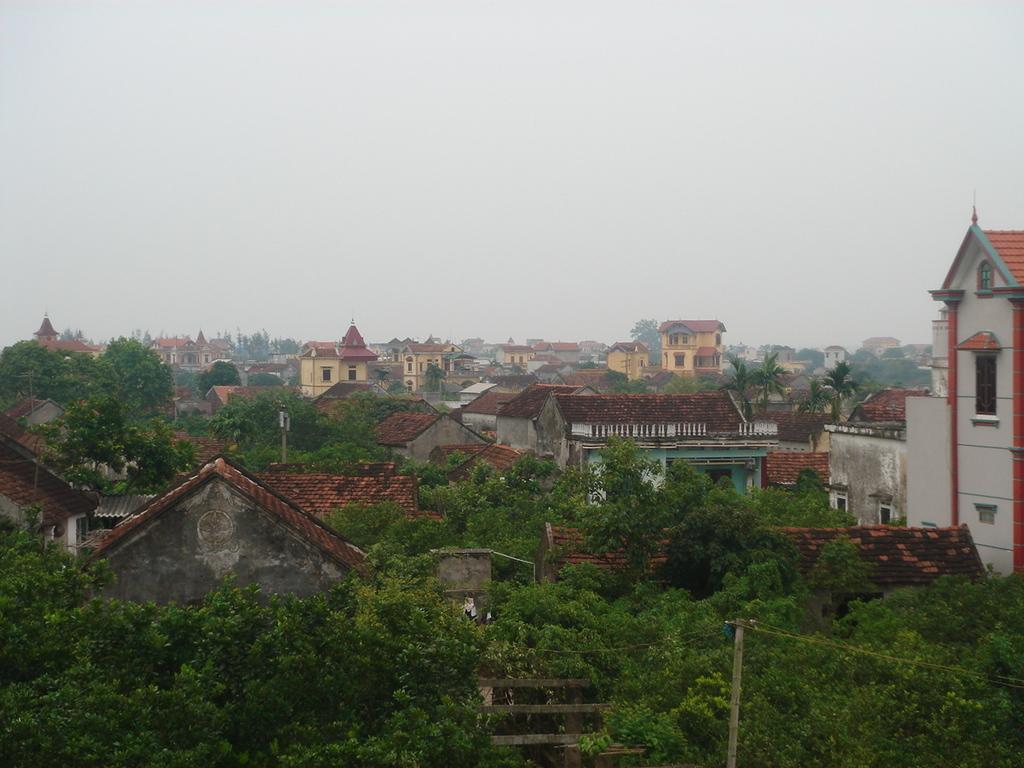Describe this image in one or two sentences. This is an outside view. At the bottom there are many trees and buildings. At the top of the image I can see the sky. 